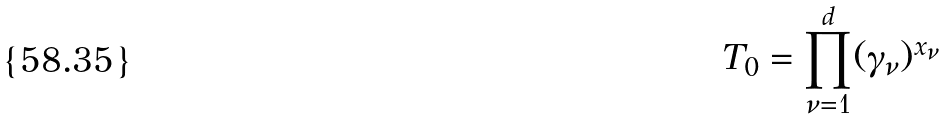<formula> <loc_0><loc_0><loc_500><loc_500>T _ { 0 } = \prod _ { \nu = 1 } ^ { d } ( \gamma _ { \nu } ) ^ { x _ { \nu } }</formula> 